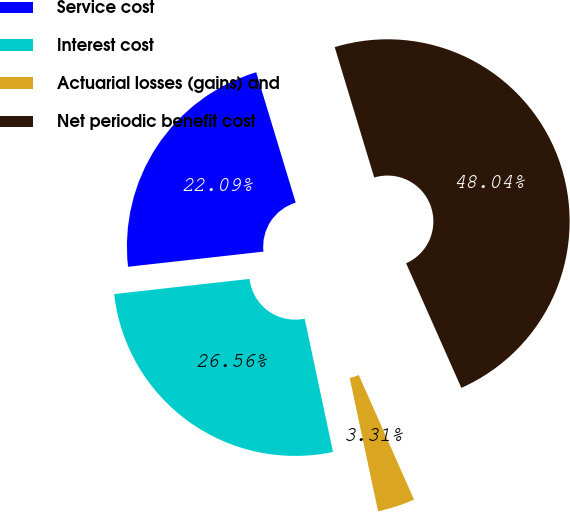Convert chart. <chart><loc_0><loc_0><loc_500><loc_500><pie_chart><fcel>Service cost<fcel>Interest cost<fcel>Actuarial losses (gains) and<fcel>Net periodic benefit cost<nl><fcel>22.09%<fcel>26.56%<fcel>3.31%<fcel>48.04%<nl></chart> 